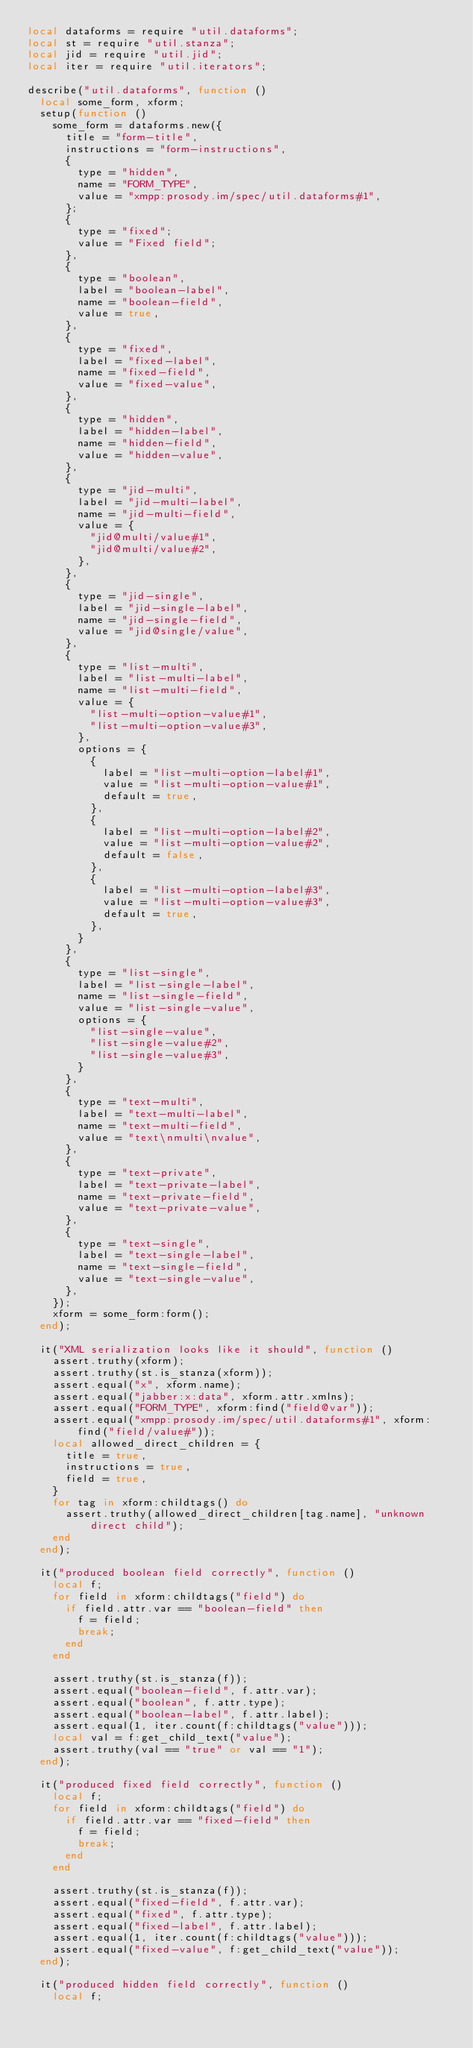<code> <loc_0><loc_0><loc_500><loc_500><_Lua_>local dataforms = require "util.dataforms";
local st = require "util.stanza";
local jid = require "util.jid";
local iter = require "util.iterators";

describe("util.dataforms", function ()
	local some_form, xform;
	setup(function ()
		some_form = dataforms.new({
			title = "form-title",
			instructions = "form-instructions",
			{
				type = "hidden",
				name = "FORM_TYPE",
				value = "xmpp:prosody.im/spec/util.dataforms#1",
			};
			{
				type = "fixed";
				value = "Fixed field";
			},
			{
				type = "boolean",
				label = "boolean-label",
				name = "boolean-field",
				value = true,
			},
			{
				type = "fixed",
				label = "fixed-label",
				name = "fixed-field",
				value = "fixed-value",
			},
			{
				type = "hidden",
				label = "hidden-label",
				name = "hidden-field",
				value = "hidden-value",
			},
			{
				type = "jid-multi",
				label = "jid-multi-label",
				name = "jid-multi-field",
				value = {
					"jid@multi/value#1",
					"jid@multi/value#2",
				},
			},
			{
				type = "jid-single",
				label = "jid-single-label",
				name = "jid-single-field",
				value = "jid@single/value",
			},
			{
				type = "list-multi",
				label = "list-multi-label",
				name = "list-multi-field",
				value = {
					"list-multi-option-value#1",
					"list-multi-option-value#3",
				},
				options = {
					{
						label = "list-multi-option-label#1",
						value = "list-multi-option-value#1",
						default = true,
					},
					{
						label = "list-multi-option-label#2",
						value = "list-multi-option-value#2",
						default = false,
					},
					{
						label = "list-multi-option-label#3",
						value = "list-multi-option-value#3",
						default = true,
					},
				}
			},
			{
				type = "list-single",
				label = "list-single-label",
				name = "list-single-field",
				value = "list-single-value",
				options = {
					"list-single-value",
					"list-single-value#2",
					"list-single-value#3",
				}
			},
			{
				type = "text-multi",
				label = "text-multi-label",
				name = "text-multi-field",
				value = "text\nmulti\nvalue",
			},
			{
				type = "text-private",
				label = "text-private-label",
				name = "text-private-field",
				value = "text-private-value",
			},
			{
				type = "text-single",
				label = "text-single-label",
				name = "text-single-field",
				value = "text-single-value",
			},
		});
		xform = some_form:form();
	end);

	it("XML serialization looks like it should", function ()
		assert.truthy(xform);
		assert.truthy(st.is_stanza(xform));
		assert.equal("x", xform.name);
		assert.equal("jabber:x:data", xform.attr.xmlns);
		assert.equal("FORM_TYPE", xform:find("field@var"));
		assert.equal("xmpp:prosody.im/spec/util.dataforms#1", xform:find("field/value#"));
		local allowed_direct_children = {
			title = true,
			instructions = true,
			field = true,
		}
		for tag in xform:childtags() do
			assert.truthy(allowed_direct_children[tag.name], "unknown direct child");
		end
	end);

	it("produced boolean field correctly", function ()
		local f;
		for field in xform:childtags("field") do
			if field.attr.var == "boolean-field" then
				f = field;
				break;
			end
		end

		assert.truthy(st.is_stanza(f));
		assert.equal("boolean-field", f.attr.var);
		assert.equal("boolean", f.attr.type);
		assert.equal("boolean-label", f.attr.label);
		assert.equal(1, iter.count(f:childtags("value")));
		local val = f:get_child_text("value");
		assert.truthy(val == "true" or val == "1");
	end);

	it("produced fixed field correctly", function ()
		local f;
		for field in xform:childtags("field") do
			if field.attr.var == "fixed-field" then
				f = field;
				break;
			end
		end

		assert.truthy(st.is_stanza(f));
		assert.equal("fixed-field", f.attr.var);
		assert.equal("fixed", f.attr.type);
		assert.equal("fixed-label", f.attr.label);
		assert.equal(1, iter.count(f:childtags("value")));
		assert.equal("fixed-value", f:get_child_text("value"));
	end);

	it("produced hidden field correctly", function ()
		local f;</code> 